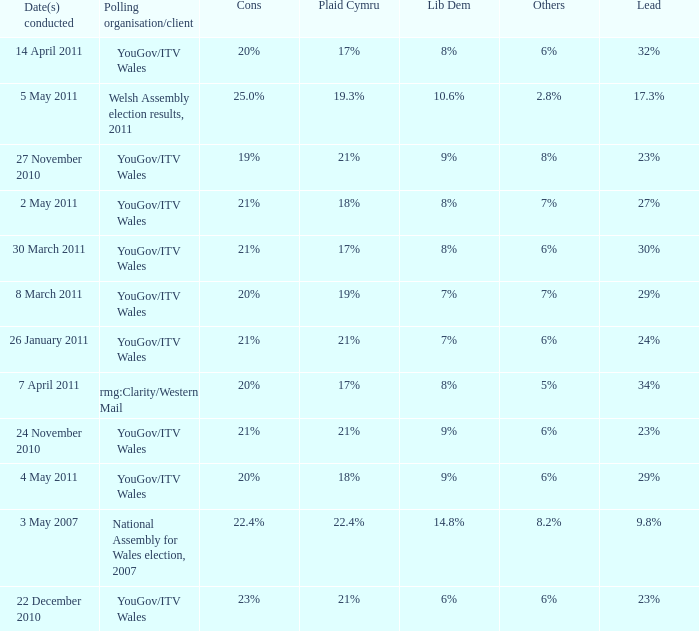Name the others for cons of 21% and lead of 24% 6%. 